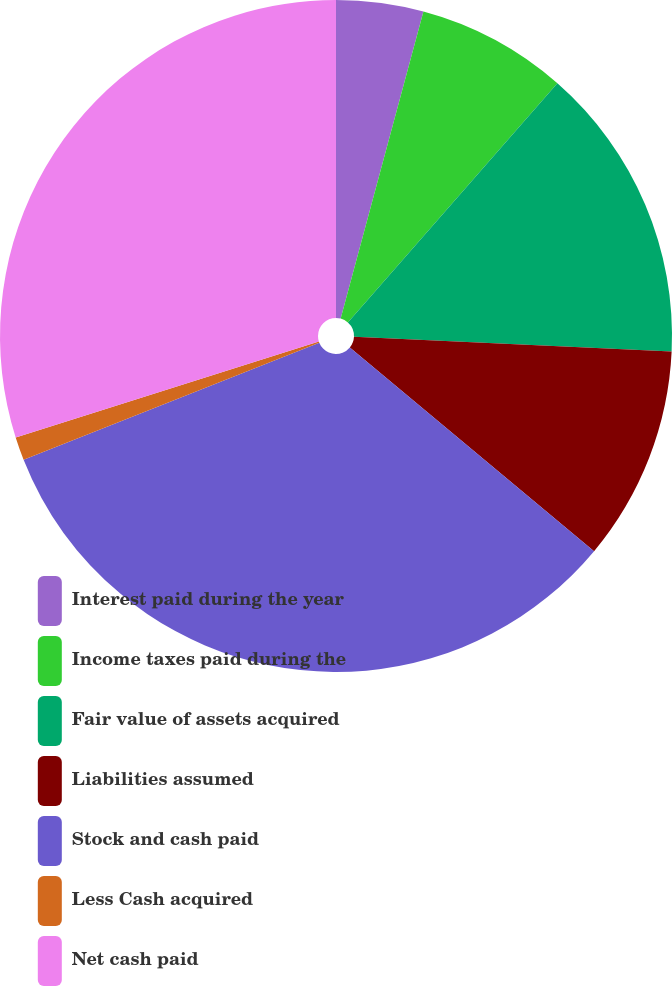<chart> <loc_0><loc_0><loc_500><loc_500><pie_chart><fcel>Interest paid during the year<fcel>Income taxes paid during the<fcel>Fair value of assets acquired<fcel>Liabilities assumed<fcel>Stock and cash paid<fcel>Less Cash acquired<fcel>Net cash paid<nl><fcel>4.19%<fcel>7.26%<fcel>14.29%<fcel>10.32%<fcel>32.94%<fcel>1.12%<fcel>29.88%<nl></chart> 